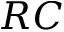<formula> <loc_0><loc_0><loc_500><loc_500>R C</formula> 